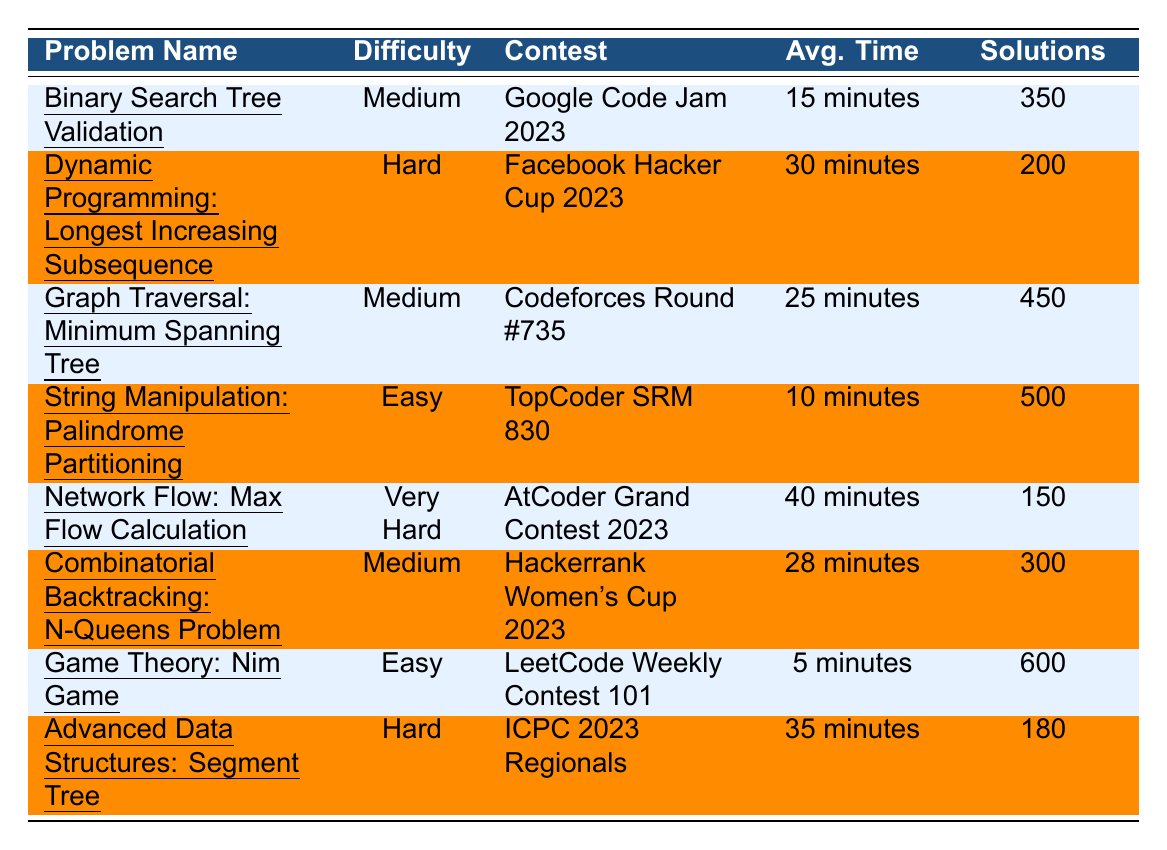What is the difficulty rating of the "Game Theory: Nim Game"? The table lists the problem "Game Theory: Nim Game" and states its difficulty rating is "Easy."
Answer: Easy Which problem has the highest number of solutions submitted? The table shows that the "Game Theory: Nim Game" has the highest number of submitted solutions, which is 600.
Answer: Game Theory: Nim Game How many problems are rated as "Medium"? By counting the entries in the table, there are four problems rated as "Medium": "Binary Search Tree Validation," "Graph Traversal: Minimum Spanning Tree," "Combinatorial Backtracking: N-Queens Problem," and "Advanced Data Structures: Segment Tree."
Answer: 4 What is the average solving time for problems rated as "Hard"? The problems rated as "Hard" are "Dynamic Programming: Longest Increasing Subsequence" (30 minutes) and "Advanced Data Structures: Segment Tree" (35 minutes). The average solving time is calculated as (30 + 35) / 2 = 32.5 minutes.
Answer: 32.5 minutes Is there any problem whose average solving time is less than 10 minutes? The table shows the lowest average solving time is for "Game Theory: Nim Game," which has an average of 5 minutes. Therefore, there is a problem with an average solving time less than 10 minutes.
Answer: Yes What is the sum of solutions submitted for problems rated as "Very Hard" and "Hard"? The only problem rated "Very Hard" is "Network Flow: Max Flow Calculation," which has 150 solutions. The "Hard" problems are "Dynamic Programming: Longest Increasing Subsequence" (200) and "Advanced Data Structures: Segment Tree" (180). The sum is calculated as 150 + 200 + 180 = 530 solutions.
Answer: 530 Which contest has the problem with the longest average solving time? Looking at the entries, the problem "Network Flow: Max Flow Calculation" in the "AtCoder Grand Contest 2023" has the longest average solving time at 40 minutes.
Answer: AtCoder Grand Contest 2023 How many more solutions were submitted for "Graph Traversal: Minimum Spanning Tree" compared to "Advanced Data Structures: Segment Tree"? "Graph Traversal: Minimum Spanning Tree" has 450 solutions submitted, while "Advanced Data Structures: Segment Tree" has 180 solutions. The difference is 450 - 180 = 270 solutions.
Answer: 270 